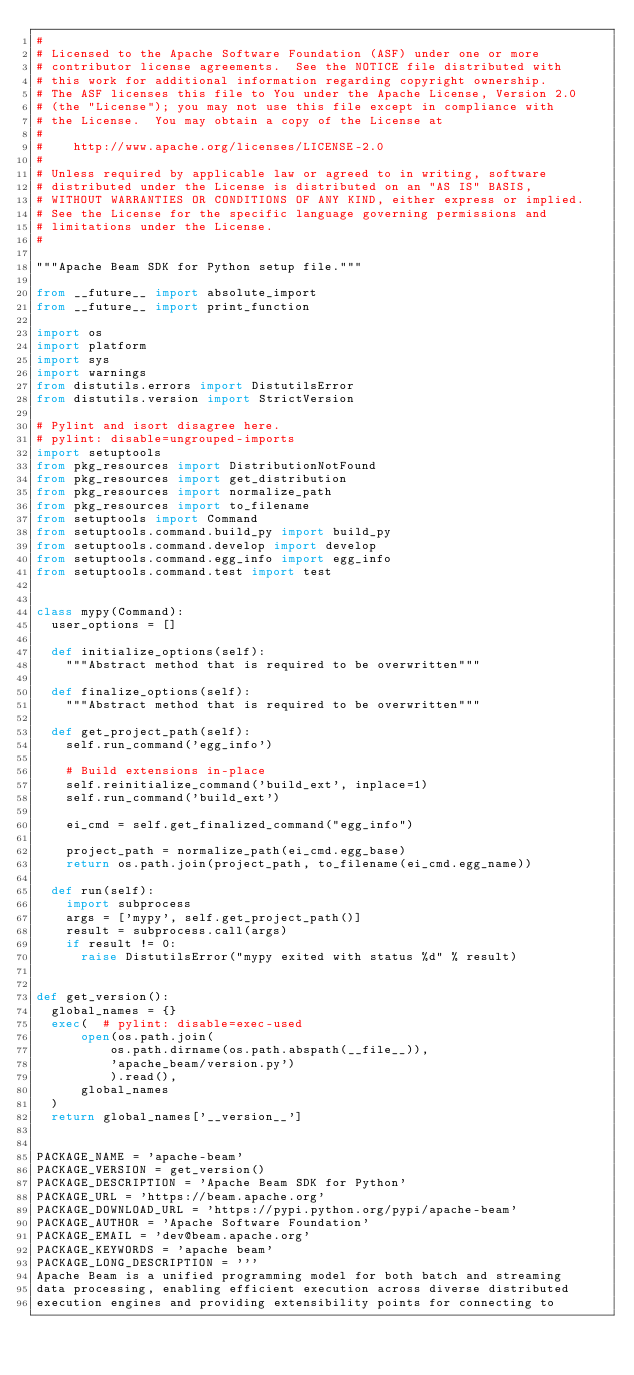Convert code to text. <code><loc_0><loc_0><loc_500><loc_500><_Python_>#
# Licensed to the Apache Software Foundation (ASF) under one or more
# contributor license agreements.  See the NOTICE file distributed with
# this work for additional information regarding copyright ownership.
# The ASF licenses this file to You under the Apache License, Version 2.0
# (the "License"); you may not use this file except in compliance with
# the License.  You may obtain a copy of the License at
#
#    http://www.apache.org/licenses/LICENSE-2.0
#
# Unless required by applicable law or agreed to in writing, software
# distributed under the License is distributed on an "AS IS" BASIS,
# WITHOUT WARRANTIES OR CONDITIONS OF ANY KIND, either express or implied.
# See the License for the specific language governing permissions and
# limitations under the License.
#

"""Apache Beam SDK for Python setup file."""

from __future__ import absolute_import
from __future__ import print_function

import os
import platform
import sys
import warnings
from distutils.errors import DistutilsError
from distutils.version import StrictVersion

# Pylint and isort disagree here.
# pylint: disable=ungrouped-imports
import setuptools
from pkg_resources import DistributionNotFound
from pkg_resources import get_distribution
from pkg_resources import normalize_path
from pkg_resources import to_filename
from setuptools import Command
from setuptools.command.build_py import build_py
from setuptools.command.develop import develop
from setuptools.command.egg_info import egg_info
from setuptools.command.test import test


class mypy(Command):
  user_options = []

  def initialize_options(self):
    """Abstract method that is required to be overwritten"""

  def finalize_options(self):
    """Abstract method that is required to be overwritten"""

  def get_project_path(self):
    self.run_command('egg_info')

    # Build extensions in-place
    self.reinitialize_command('build_ext', inplace=1)
    self.run_command('build_ext')

    ei_cmd = self.get_finalized_command("egg_info")

    project_path = normalize_path(ei_cmd.egg_base)
    return os.path.join(project_path, to_filename(ei_cmd.egg_name))

  def run(self):
    import subprocess
    args = ['mypy', self.get_project_path()]
    result = subprocess.call(args)
    if result != 0:
      raise DistutilsError("mypy exited with status %d" % result)


def get_version():
  global_names = {}
  exec(  # pylint: disable=exec-used
      open(os.path.join(
          os.path.dirname(os.path.abspath(__file__)),
          'apache_beam/version.py')
          ).read(),
      global_names
  )
  return global_names['__version__']


PACKAGE_NAME = 'apache-beam'
PACKAGE_VERSION = get_version()
PACKAGE_DESCRIPTION = 'Apache Beam SDK for Python'
PACKAGE_URL = 'https://beam.apache.org'
PACKAGE_DOWNLOAD_URL = 'https://pypi.python.org/pypi/apache-beam'
PACKAGE_AUTHOR = 'Apache Software Foundation'
PACKAGE_EMAIL = 'dev@beam.apache.org'
PACKAGE_KEYWORDS = 'apache beam'
PACKAGE_LONG_DESCRIPTION = '''
Apache Beam is a unified programming model for both batch and streaming
data processing, enabling efficient execution across diverse distributed
execution engines and providing extensibility points for connecting to</code> 